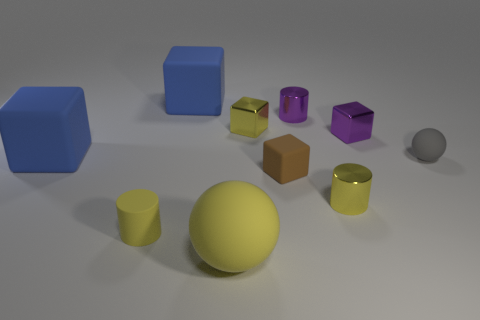Subtract all purple cylinders. How many cylinders are left? 2 Subtract all tiny shiny cylinders. How many cylinders are left? 1 Subtract all cylinders. How many objects are left? 7 Add 1 small purple matte blocks. How many small purple matte blocks exist? 1 Subtract 1 yellow cylinders. How many objects are left? 9 Subtract all yellow spheres. Subtract all purple cubes. How many spheres are left? 1 Subtract all green spheres. How many purple cylinders are left? 1 Subtract all yellow metallic blocks. Subtract all small gray matte spheres. How many objects are left? 8 Add 5 small yellow rubber objects. How many small yellow rubber objects are left? 6 